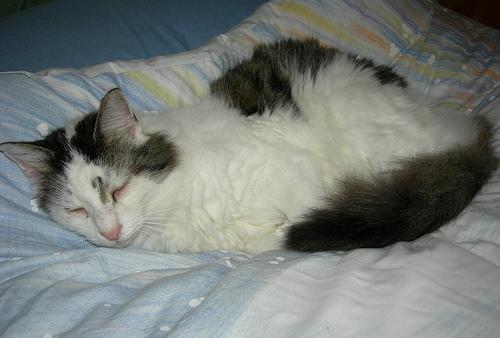How many cats are there?
Give a very brief answer. 1. 